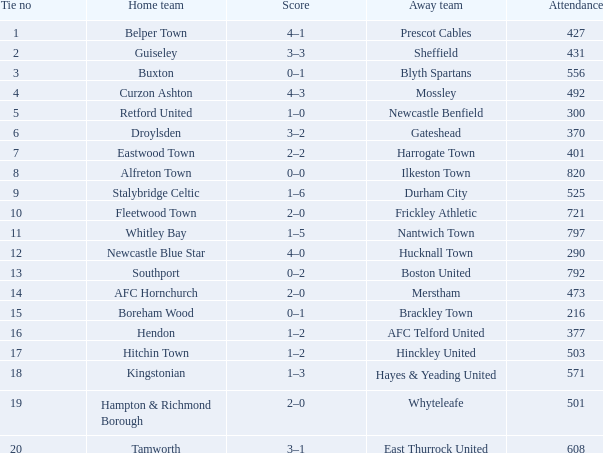What was the score for home team AFC Hornchurch? 2–0. Would you mind parsing the complete table? {'header': ['Tie no', 'Home team', 'Score', 'Away team', 'Attendance'], 'rows': [['1', 'Belper Town', '4–1', 'Prescot Cables', '427'], ['2', 'Guiseley', '3–3', 'Sheffield', '431'], ['3', 'Buxton', '0–1', 'Blyth Spartans', '556'], ['4', 'Curzon Ashton', '4–3', 'Mossley', '492'], ['5', 'Retford United', '1–0', 'Newcastle Benfield', '300'], ['6', 'Droylsden', '3–2', 'Gateshead', '370'], ['7', 'Eastwood Town', '2–2', 'Harrogate Town', '401'], ['8', 'Alfreton Town', '0–0', 'Ilkeston Town', '820'], ['9', 'Stalybridge Celtic', '1–6', 'Durham City', '525'], ['10', 'Fleetwood Town', '2–0', 'Frickley Athletic', '721'], ['11', 'Whitley Bay', '1–5', 'Nantwich Town', '797'], ['12', 'Newcastle Blue Star', '4–0', 'Hucknall Town', '290'], ['13', 'Southport', '0–2', 'Boston United', '792'], ['14', 'AFC Hornchurch', '2–0', 'Merstham', '473'], ['15', 'Boreham Wood', '0–1', 'Brackley Town', '216'], ['16', 'Hendon', '1–2', 'AFC Telford United', '377'], ['17', 'Hitchin Town', '1–2', 'Hinckley United', '503'], ['18', 'Kingstonian', '1–3', 'Hayes & Yeading United', '571'], ['19', 'Hampton & Richmond Borough', '2–0', 'Whyteleafe', '501'], ['20', 'Tamworth', '3–1', 'East Thurrock United', '608']]} 